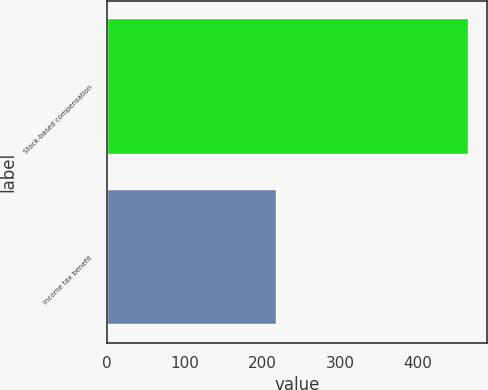Convert chart. <chart><loc_0><loc_0><loc_500><loc_500><bar_chart><fcel>Stock-based compensation<fcel>Income tax benefit<nl><fcel>466<fcel>219<nl></chart> 